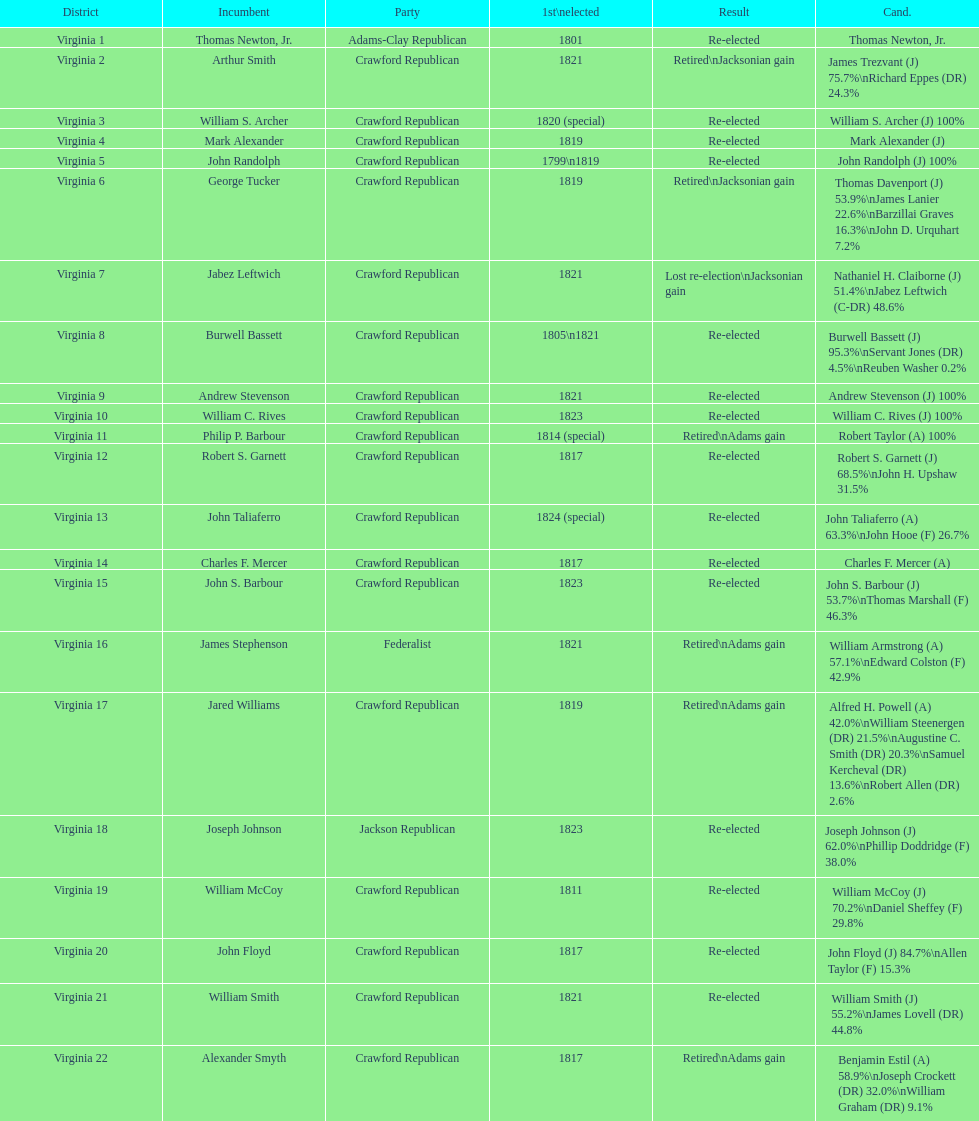How many candidates were there for virginia 17 district? 5. 